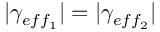Convert formula to latex. <formula><loc_0><loc_0><loc_500><loc_500>| \gamma _ { e f f _ { 1 } } | = | \gamma _ { e f f _ { 2 } } |</formula> 